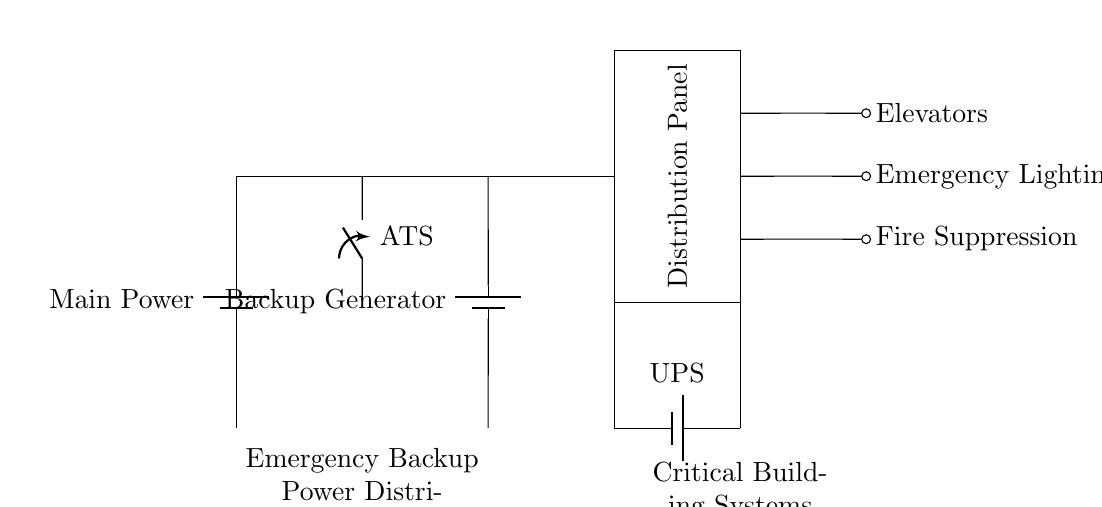What is the main power source in this circuit? The main power source is the battery labeled 'Main Power' located at the left side of the circuit diagram. This is the primary source of power that feeds into the system.
Answer: Main Power What is the function of the ATS in this circuit? The ATS, or Automatic Transfer Switch, serves as a switch that automatically transfers power from the main power source to the backup generator when it detects a failure in the main source.
Answer: Automatic Transfer Switch Which system is supported by the UPS in the circuit? The UPS, or Uninterruptible Power Supply, is connected to the distribution panel and supports critical loads such as elevators, emergency lighting, and fire suppression.
Answer: Critical loads How many critical loads are shown in the diagram? There are three critical loads depicted in the circuit: Elevators, Emergency Lighting, and Fire Suppression. These loads are vital for safety and operations during a power failure.
Answer: Three What does the distribution panel do? The distribution panel takes the power from the ATS (and the UPS) and distributes it to various critical systems within the building, ensuring that they remain operational even during power disruptions.
Answer: Distributes power 